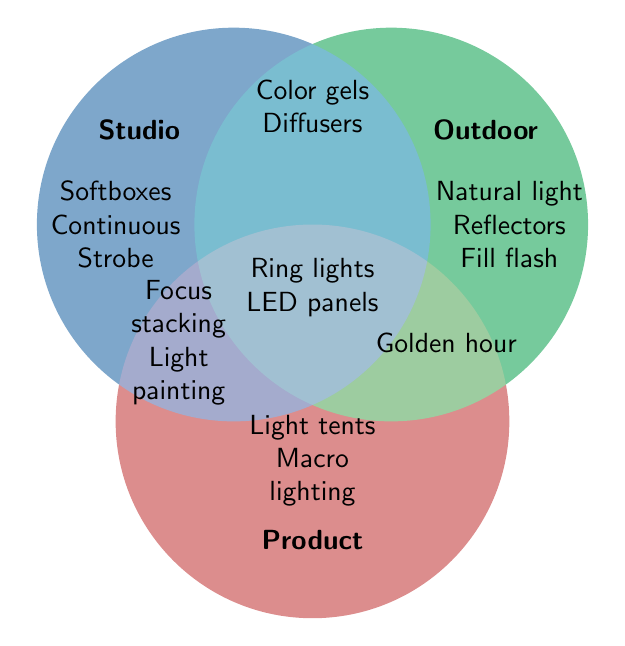What lighting technique is unique to outdoor photography? Look at the section labeled "Outdoor" for techniques that do not overlap with other categories.
Answer: Natural light, Reflectors, Fill flash Which technique is used in all three photography categories? Find the intersection point where all three circles overlap.
Answer: Ring lights, LED panels Which two techniques are shared between studio and outdoor photography? Look for the section where "Studio" and "Outdoor" circles overlap without intersecting "Product".
Answer: Color gels, Diffusers How many lighting techniques are unique to product photography? Check the section labeled "Product" that does not overlap with other circles.
Answer: Two Which technique is shared between studio and product photography but not with outdoor photography? Look at the section where "Studio" and "Product" overlap without intersecting "Outdoor".
Answer: Focus stacking, Light painting Which technique is common to both outdoor and product photography but not studio photography? Look at the overlapping section between "Outdoor" and "Product" circles without intersecting "Studio".
Answer: Golden hour 